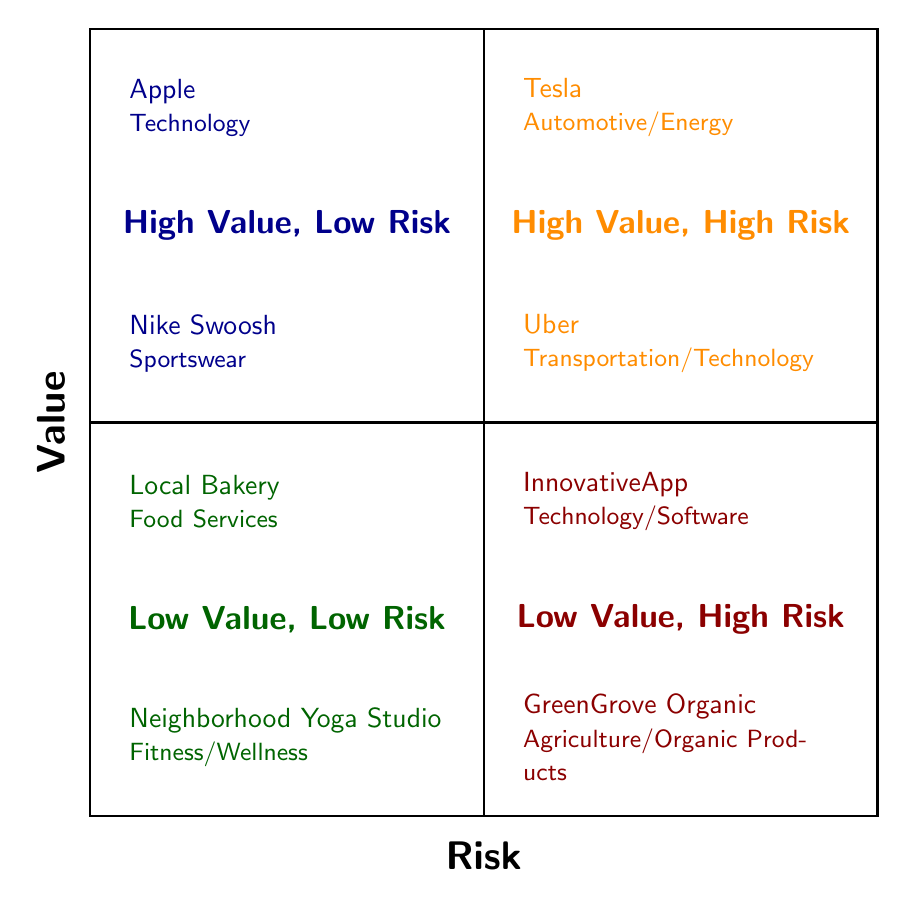What trademarks appear in the High Value, Low Risk quadrant? The High Value, Low Risk quadrant contains two trademarks, "Apple" and "Nike Swoosh." I identify these by referring to the dark blue section, which provides a list of trademarks in that category.
Answer: Apple, Nike Swoosh Which categories are represented in the Low Value, High Risk quadrant? The Low Value, High Risk quadrant features two trademarks, each belonging to a different category: "InnovativeApp" (Technology/Software) and "GreenGrove Organic" (Agriculture/Organic Products). This means there are two distinct categories represented.
Answer: Technology/Software, Agriculture/Organic Products How many trademarks are listed in the High Value, High Risk quadrant? The High Value, High Risk quadrant includes two trademarks: "Tesla" and "Uber." By counting the entries in the orange section of the diagram, I confirm that there are precisely two trademarks.
Answer: 2 What is the primary risk associated with the trademark "InnovativeApp"? The trademark "InnovativeApp," located in the Low Value, High Risk quadrant, is described as being vulnerable to legal challenges due to naming conflicts and similar existing trademarks. I determine this by reading the description provided in the dark red section where this trademark is placed.
Answer: Vulnerable to legal challenges Which quadrant contains both high-value and high-risk trademarks? The High Value, High Risk quadrant, indicated by the orange section of the diagram, contains trademarks that are both high-value and high-risk. Notably, these trademarks are "Tesla" and "Uber," which I identify from the entries in that quadrant.
Answer: High Value, High Risk In which quadrant is "Local Bakery" located? The "Local Bakery" trademark is situated in the Low Value, Low Risk quadrant, marked by the dark green section of the diagram. I locate this trademark by looking for it within the specified area dedicated to low-value, low-risk trademarks.
Answer: Low Value, Low Risk Which trademark is categorized under Sportswear and has low risk? The trademark categorized under Sportswear that has low risk is "Nike Swoosh." I arrive at this answer by analyzing the High Value, Low Risk quadrant where this trademark is listed along with its category label.
Answer: Nike Swoosh What is the primary concern for the trademark "Uber"? The primary concern for "Uber," found in the High Value, High Risk quadrant, is that it is prone to frequent legal challenges and disputes over trademark rights. This conclusion is reached by examining the description in the orange quadrant where "Uber" is placed.
Answer: Frequent legal challenges What attracts risk to the trademark "GreenGrove Organic"? The risk for the trademark "GreenGrove Organic" arises from its potential commonality in naming and market saturation-related disputes. This information is derived from the description in the Low Value, High Risk quadrant of the diagram.
Answer: Commonality in naming and potential for market saturation-related disputes 